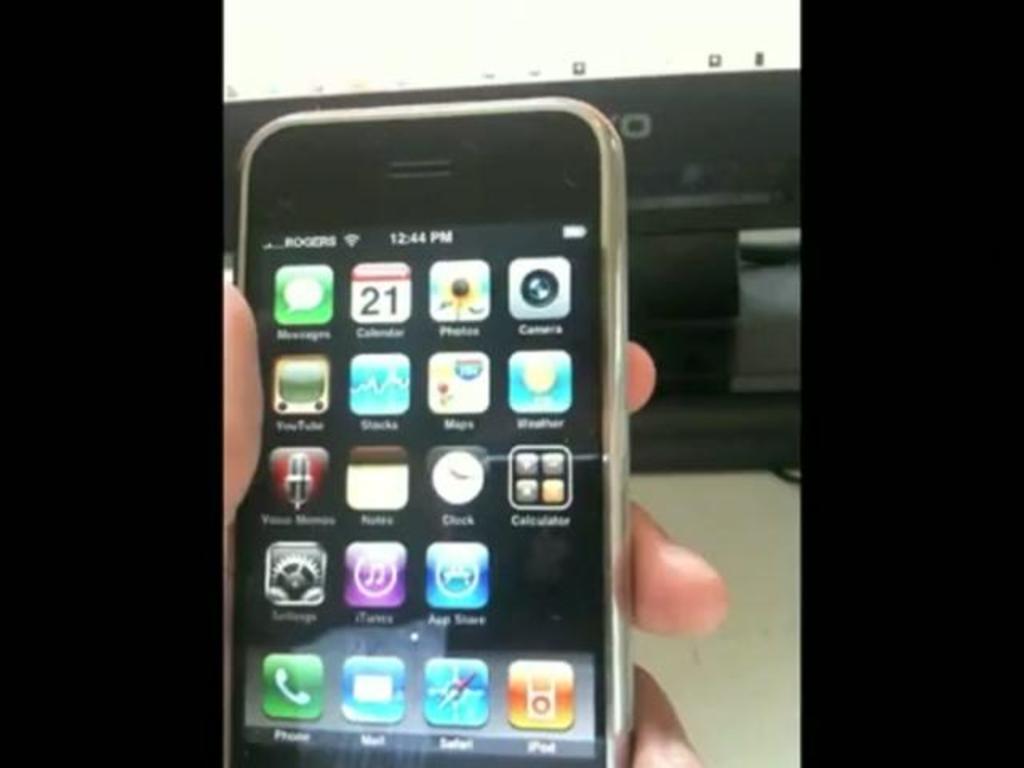What is the cellular network the phone is one?
Your answer should be compact. Rogers. Rockers mobile netowork?
Offer a very short reply. Yes. 